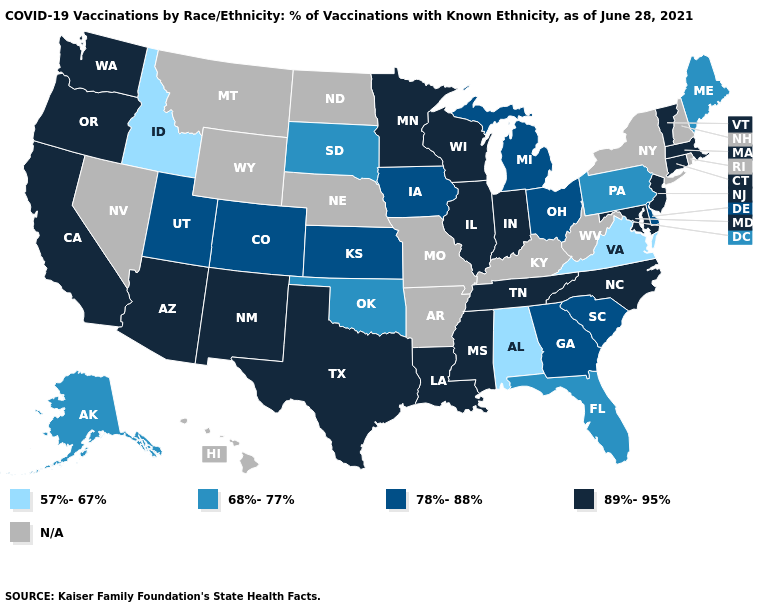Among the states that border North Carolina , which have the highest value?
Short answer required. Tennessee. What is the value of Hawaii?
Concise answer only. N/A. What is the lowest value in the USA?
Write a very short answer. 57%-67%. Among the states that border Florida , which have the lowest value?
Short answer required. Alabama. Does Utah have the highest value in the USA?
Answer briefly. No. Does the map have missing data?
Write a very short answer. Yes. What is the value of Utah?
Be succinct. 78%-88%. Name the states that have a value in the range 89%-95%?
Keep it brief. Arizona, California, Connecticut, Illinois, Indiana, Louisiana, Maryland, Massachusetts, Minnesota, Mississippi, New Jersey, New Mexico, North Carolina, Oregon, Tennessee, Texas, Vermont, Washington, Wisconsin. Name the states that have a value in the range 78%-88%?
Short answer required. Colorado, Delaware, Georgia, Iowa, Kansas, Michigan, Ohio, South Carolina, Utah. What is the value of Kentucky?
Keep it brief. N/A. Does Illinois have the lowest value in the MidWest?
Answer briefly. No. Does Kansas have the highest value in the MidWest?
Quick response, please. No. Name the states that have a value in the range 57%-67%?
Answer briefly. Alabama, Idaho, Virginia. Among the states that border Nebraska , does South Dakota have the highest value?
Short answer required. No. 